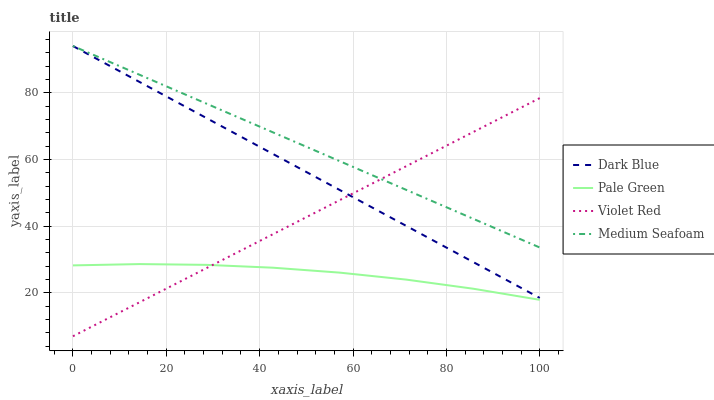Does Pale Green have the minimum area under the curve?
Answer yes or no. Yes. Does Medium Seafoam have the maximum area under the curve?
Answer yes or no. Yes. Does Violet Red have the minimum area under the curve?
Answer yes or no. No. Does Violet Red have the maximum area under the curve?
Answer yes or no. No. Is Violet Red the smoothest?
Answer yes or no. Yes. Is Pale Green the roughest?
Answer yes or no. Yes. Is Pale Green the smoothest?
Answer yes or no. No. Is Violet Red the roughest?
Answer yes or no. No. Does Violet Red have the lowest value?
Answer yes or no. Yes. Does Pale Green have the lowest value?
Answer yes or no. No. Does Medium Seafoam have the highest value?
Answer yes or no. Yes. Does Violet Red have the highest value?
Answer yes or no. No. Is Pale Green less than Medium Seafoam?
Answer yes or no. Yes. Is Dark Blue greater than Pale Green?
Answer yes or no. Yes. Does Violet Red intersect Pale Green?
Answer yes or no. Yes. Is Violet Red less than Pale Green?
Answer yes or no. No. Is Violet Red greater than Pale Green?
Answer yes or no. No. Does Pale Green intersect Medium Seafoam?
Answer yes or no. No. 